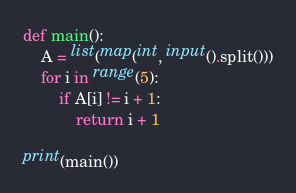<code> <loc_0><loc_0><loc_500><loc_500><_Python_>def main():
    A = list(map(int, input().split()))
    for i in range(5):
        if A[i] != i + 1:
            return i + 1

print(main())
</code> 